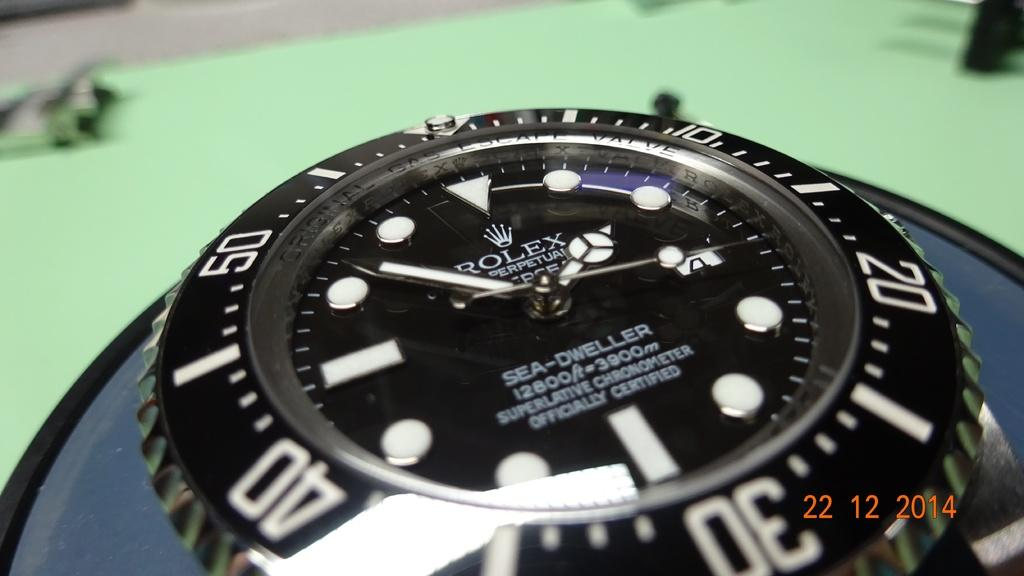<image>
Offer a succinct explanation of the picture presented. A close up picture of a Rolex water was taken in 2014. 